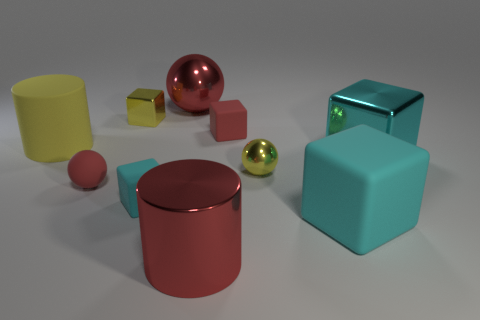Subtract all rubber spheres. How many spheres are left? 2 Subtract all yellow blocks. How many blocks are left? 4 Subtract all green spheres. Subtract all green cubes. How many spheres are left? 3 Subtract all red cylinders. How many blue blocks are left? 0 Subtract all large purple cylinders. Subtract all large cyan things. How many objects are left? 8 Add 5 red metallic things. How many red metallic things are left? 7 Add 7 large blocks. How many large blocks exist? 9 Subtract 1 yellow spheres. How many objects are left? 9 Subtract all cylinders. How many objects are left? 8 Subtract 3 cubes. How many cubes are left? 2 